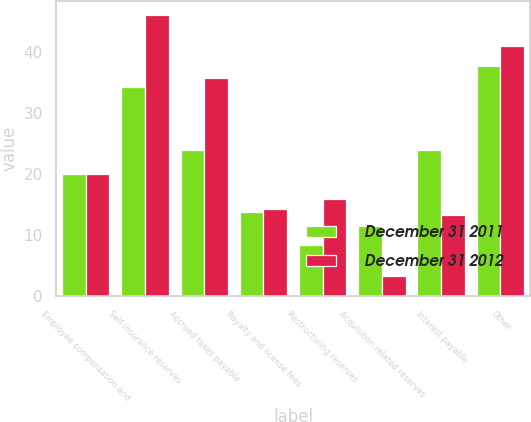Convert chart to OTSL. <chart><loc_0><loc_0><loc_500><loc_500><stacked_bar_chart><ecel><fcel>Employee compensation and<fcel>Self-insurance reserves<fcel>Accrued taxes payable<fcel>Royalty and license fees<fcel>Restructuring reserves<fcel>Acquisition related reserves<fcel>Interest payable<fcel>Other<nl><fcel>December 31 2011<fcel>20<fcel>34.2<fcel>24<fcel>13.8<fcel>8.4<fcel>11.5<fcel>24<fcel>37.7<nl><fcel>December 31 2012<fcel>20<fcel>46<fcel>35.8<fcel>14.3<fcel>16<fcel>3.3<fcel>13.3<fcel>41<nl></chart> 